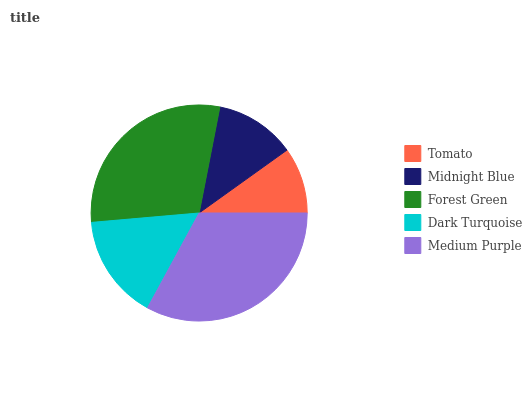Is Tomato the minimum?
Answer yes or no. Yes. Is Medium Purple the maximum?
Answer yes or no. Yes. Is Midnight Blue the minimum?
Answer yes or no. No. Is Midnight Blue the maximum?
Answer yes or no. No. Is Midnight Blue greater than Tomato?
Answer yes or no. Yes. Is Tomato less than Midnight Blue?
Answer yes or no. Yes. Is Tomato greater than Midnight Blue?
Answer yes or no. No. Is Midnight Blue less than Tomato?
Answer yes or no. No. Is Dark Turquoise the high median?
Answer yes or no. Yes. Is Dark Turquoise the low median?
Answer yes or no. Yes. Is Medium Purple the high median?
Answer yes or no. No. Is Tomato the low median?
Answer yes or no. No. 